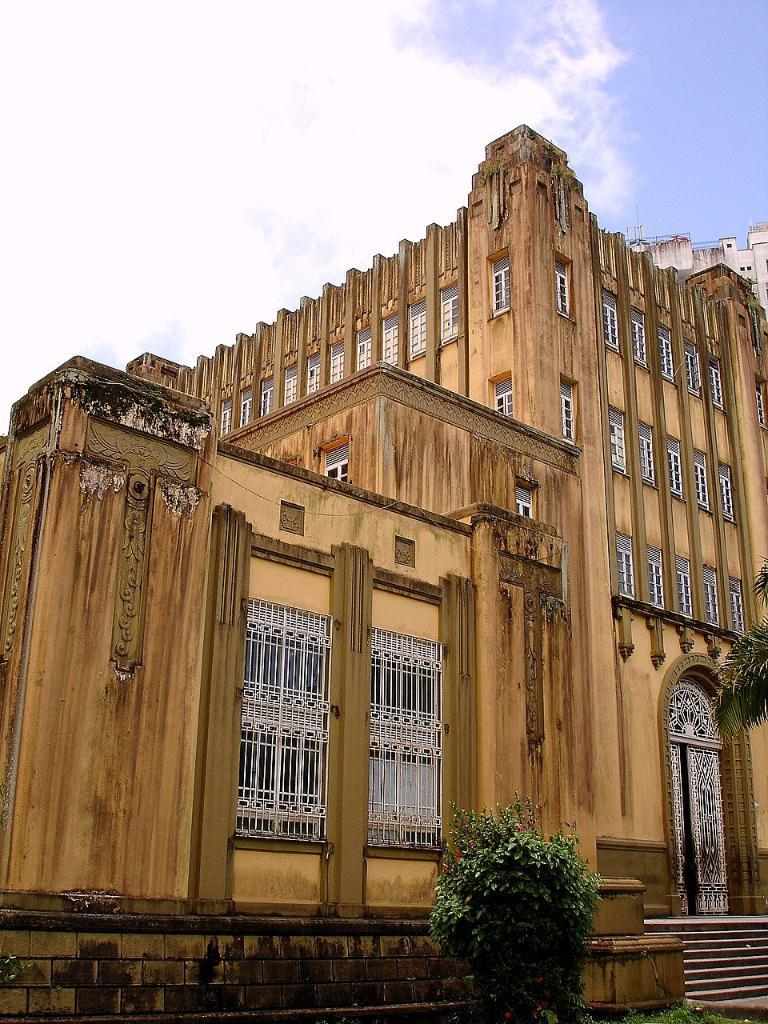What type of living organism can be seen in the image? There is a plant in the image. What type of structure is visible in the image? There is a building in the image. What color is the building? The building is cream-colored. What can be seen in the background of the image? There is a sky visible in the background of the image. What is present in the sky? Clouds are present in the sky. What type of horse is depicted in the image? There is no horse present in the image. How does the brother interact with the plant in the image? There is no brother present in the image, so it is not possible to describe any interaction with the plant. 